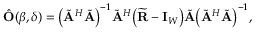<formula> <loc_0><loc_0><loc_500><loc_500>\begin{array} { r } { \hat { O } ( \beta , \delta ) = \left ( \tilde { A } ^ { H } \tilde { A } \right ) ^ { - 1 } \tilde { A } ^ { H } \left ( \widetilde { R } - I _ { W } \right ) \tilde { A } \left ( \tilde { A } ^ { H } \tilde { A } \right ) ^ { - 1 } , } \end{array}</formula> 